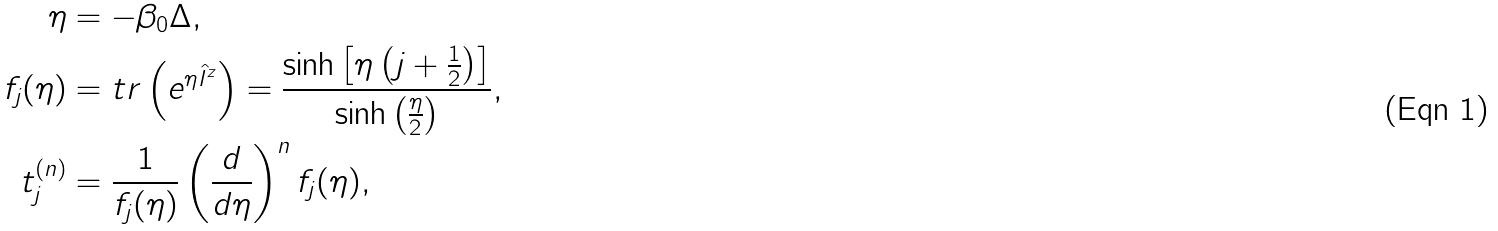<formula> <loc_0><loc_0><loc_500><loc_500>\eta & = - \beta _ { 0 } \Delta , \\ f _ { j } ( \eta ) & = t r \left ( e ^ { \eta \hat { I } ^ { z } } \right ) = \frac { \sinh \left [ \eta \left ( j + \frac { 1 } { 2 } \right ) \right ] } { \sinh \left ( \frac { \eta } { 2 } \right ) } , \\ t _ { j } ^ { ( n ) } & = \frac { 1 } { f _ { j } ( \eta ) } \left ( \frac { d } { d \eta } \right ) ^ { n } f _ { j } ( \eta ) ,</formula> 